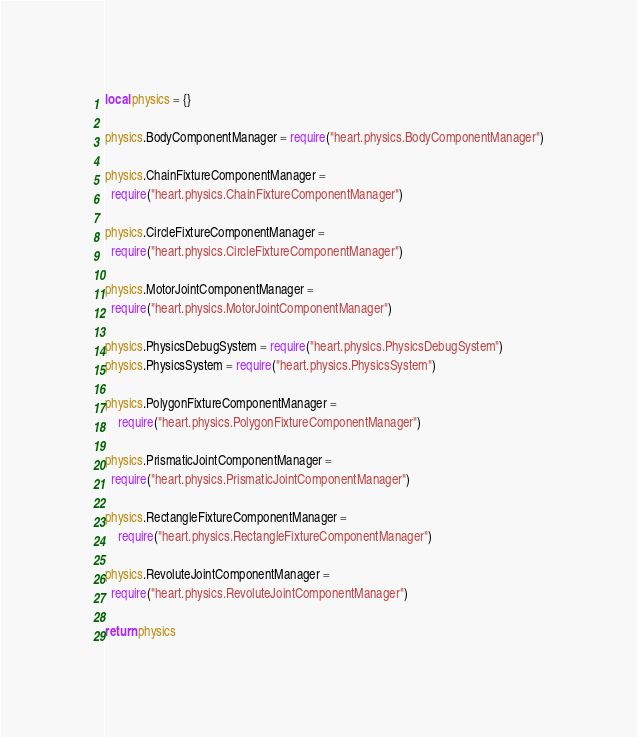<code> <loc_0><loc_0><loc_500><loc_500><_Lua_>local physics = {}

physics.BodyComponentManager = require("heart.physics.BodyComponentManager")

physics.ChainFixtureComponentManager =
  require("heart.physics.ChainFixtureComponentManager")

physics.CircleFixtureComponentManager =
  require("heart.physics.CircleFixtureComponentManager")

physics.MotorJointComponentManager =
  require("heart.physics.MotorJointComponentManager")

physics.PhysicsDebugSystem = require("heart.physics.PhysicsDebugSystem")
physics.PhysicsSystem = require("heart.physics.PhysicsSystem")

physics.PolygonFixtureComponentManager =
    require("heart.physics.PolygonFixtureComponentManager")

physics.PrismaticJointComponentManager =
  require("heart.physics.PrismaticJointComponentManager")

physics.RectangleFixtureComponentManager =
    require("heart.physics.RectangleFixtureComponentManager")

physics.RevoluteJointComponentManager =
  require("heart.physics.RevoluteJointComponentManager")

return physics
</code> 